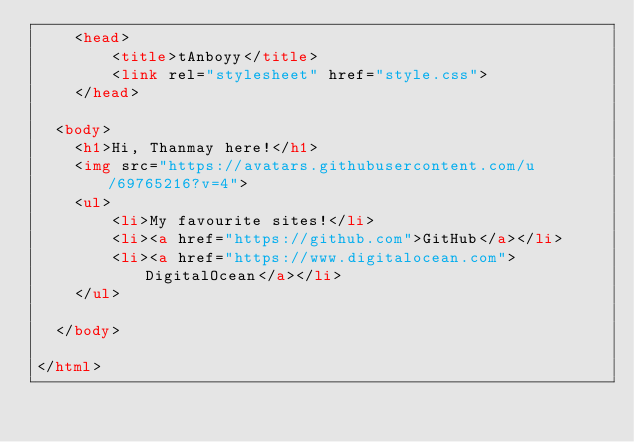<code> <loc_0><loc_0><loc_500><loc_500><_HTML_>    <head>
        <title>tAnboyy</title>
        <link rel="stylesheet" href="style.css">
    </head>

  <body>
    <h1>Hi, Thanmay here!</h1>
    <img src="https://avatars.githubusercontent.com/u/69765216?v=4">
    <ul>
        <li>My favourite sites!</li>
        <li><a href="https://github.com">GitHub</a></li>
        <li><a href="https://www.digitalocean.com">DigitalOcean</a></li>
    </ul>

  </body>

</html>
</code> 